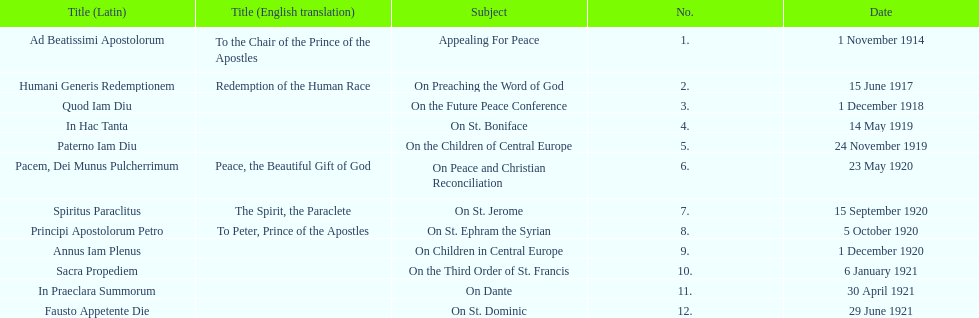How long after quod iam diu was paterno iam diu issued? 11 months. 